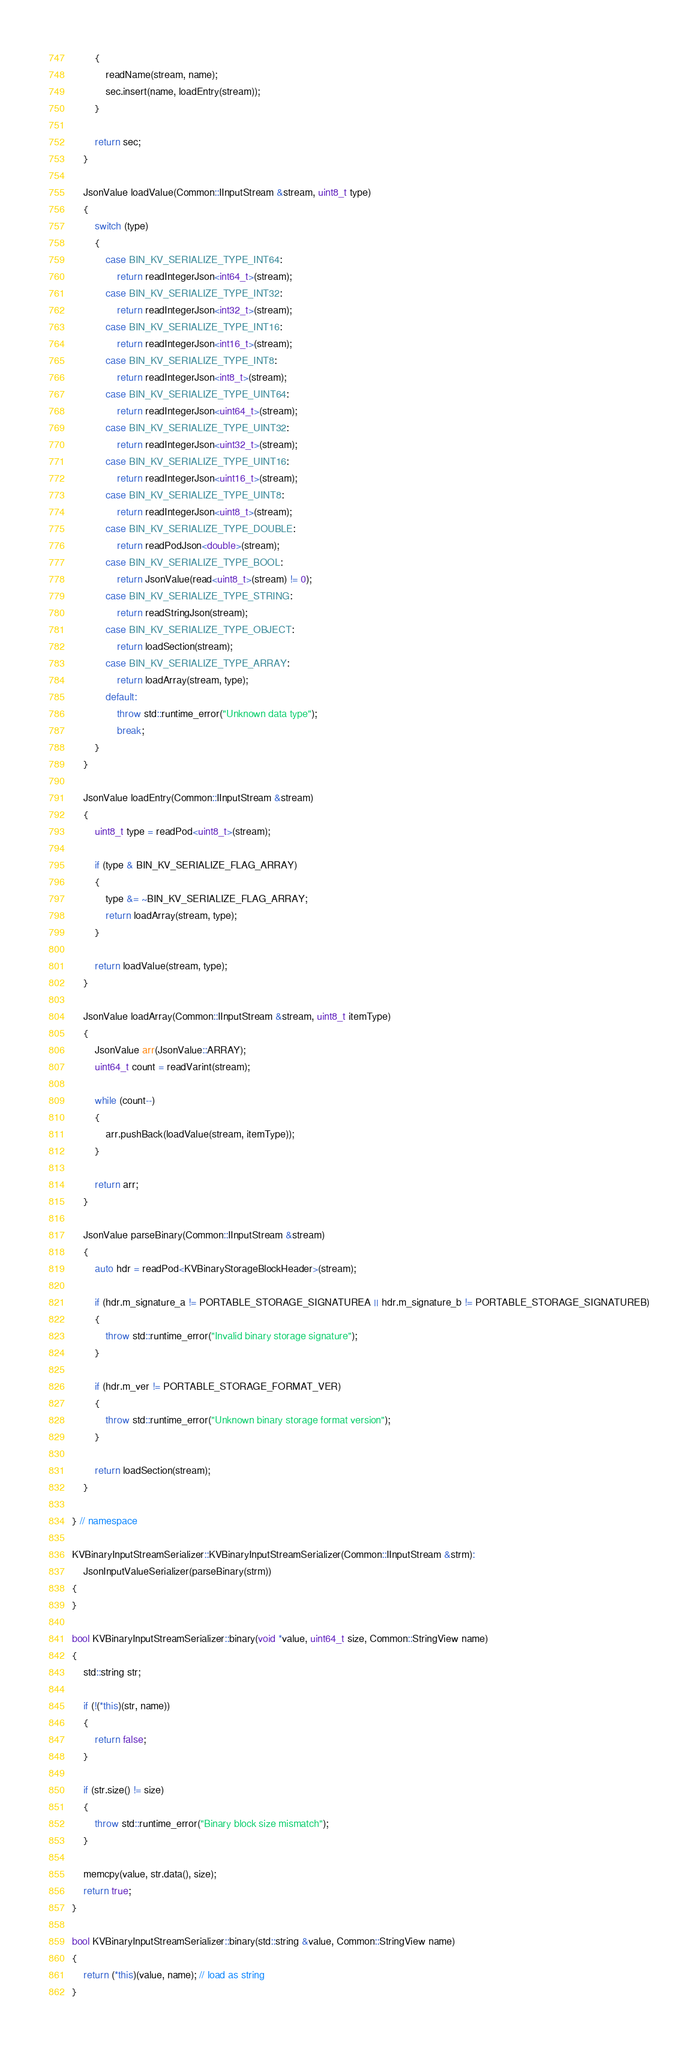Convert code to text. <code><loc_0><loc_0><loc_500><loc_500><_C++_>        {
            readName(stream, name);
            sec.insert(name, loadEntry(stream));
        }

        return sec;
    }

    JsonValue loadValue(Common::IInputStream &stream, uint8_t type)
    {
        switch (type)
        {
            case BIN_KV_SERIALIZE_TYPE_INT64:
                return readIntegerJson<int64_t>(stream);
            case BIN_KV_SERIALIZE_TYPE_INT32:
                return readIntegerJson<int32_t>(stream);
            case BIN_KV_SERIALIZE_TYPE_INT16:
                return readIntegerJson<int16_t>(stream);
            case BIN_KV_SERIALIZE_TYPE_INT8:
                return readIntegerJson<int8_t>(stream);
            case BIN_KV_SERIALIZE_TYPE_UINT64:
                return readIntegerJson<uint64_t>(stream);
            case BIN_KV_SERIALIZE_TYPE_UINT32:
                return readIntegerJson<uint32_t>(stream);
            case BIN_KV_SERIALIZE_TYPE_UINT16:
                return readIntegerJson<uint16_t>(stream);
            case BIN_KV_SERIALIZE_TYPE_UINT8:
                return readIntegerJson<uint8_t>(stream);
            case BIN_KV_SERIALIZE_TYPE_DOUBLE:
                return readPodJson<double>(stream);
            case BIN_KV_SERIALIZE_TYPE_BOOL:
                return JsonValue(read<uint8_t>(stream) != 0);
            case BIN_KV_SERIALIZE_TYPE_STRING:
                return readStringJson(stream);
            case BIN_KV_SERIALIZE_TYPE_OBJECT:
                return loadSection(stream);
            case BIN_KV_SERIALIZE_TYPE_ARRAY:
                return loadArray(stream, type);
            default:
                throw std::runtime_error("Unknown data type");
                break;
        }
    }

    JsonValue loadEntry(Common::IInputStream &stream)
    {
        uint8_t type = readPod<uint8_t>(stream);

        if (type & BIN_KV_SERIALIZE_FLAG_ARRAY)
        {
            type &= ~BIN_KV_SERIALIZE_FLAG_ARRAY;
            return loadArray(stream, type);
        }

        return loadValue(stream, type);
    }

    JsonValue loadArray(Common::IInputStream &stream, uint8_t itemType)
    {
        JsonValue arr(JsonValue::ARRAY);
        uint64_t count = readVarint(stream);

        while (count--)
        {
            arr.pushBack(loadValue(stream, itemType));
        }

        return arr;
    }

    JsonValue parseBinary(Common::IInputStream &stream)
    {
        auto hdr = readPod<KVBinaryStorageBlockHeader>(stream);

        if (hdr.m_signature_a != PORTABLE_STORAGE_SIGNATUREA || hdr.m_signature_b != PORTABLE_STORAGE_SIGNATUREB)
        {
            throw std::runtime_error("Invalid binary storage signature");
        }

        if (hdr.m_ver != PORTABLE_STORAGE_FORMAT_VER)
        {
            throw std::runtime_error("Unknown binary storage format version");
        }

        return loadSection(stream);
    }

} // namespace

KVBinaryInputStreamSerializer::KVBinaryInputStreamSerializer(Common::IInputStream &strm):
    JsonInputValueSerializer(parseBinary(strm))
{
}

bool KVBinaryInputStreamSerializer::binary(void *value, uint64_t size, Common::StringView name)
{
    std::string str;

    if (!(*this)(str, name))
    {
        return false;
    }

    if (str.size() != size)
    {
        throw std::runtime_error("Binary block size mismatch");
    }

    memcpy(value, str.data(), size);
    return true;
}

bool KVBinaryInputStreamSerializer::binary(std::string &value, Common::StringView name)
{
    return (*this)(value, name); // load as string
}
</code> 